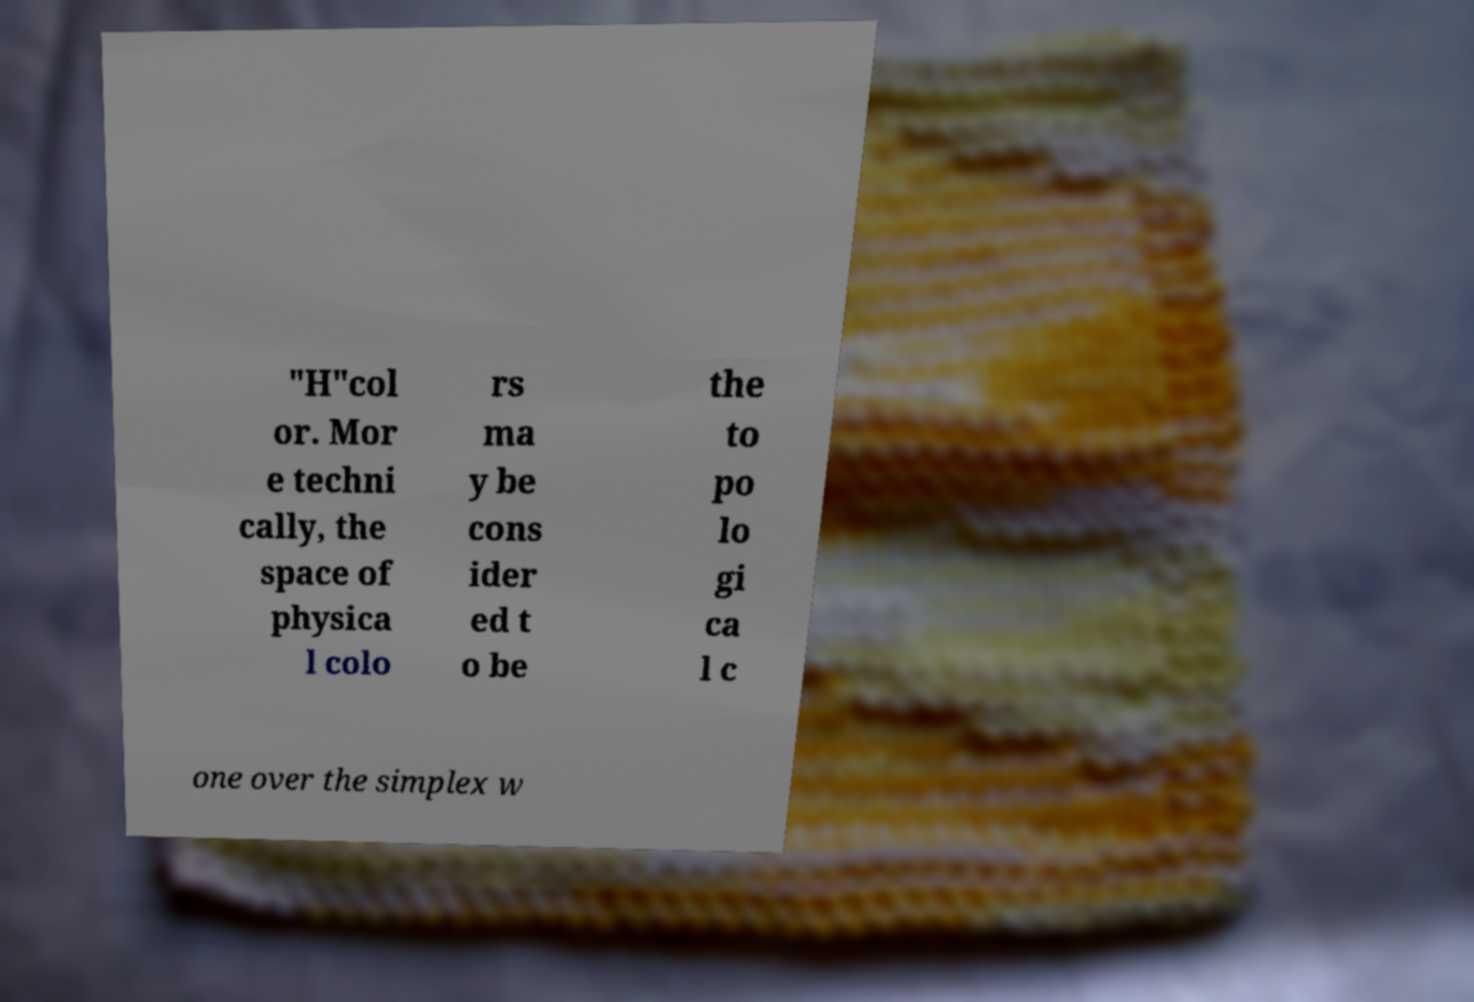For documentation purposes, I need the text within this image transcribed. Could you provide that? "H"col or. Mor e techni cally, the space of physica l colo rs ma y be cons ider ed t o be the to po lo gi ca l c one over the simplex w 